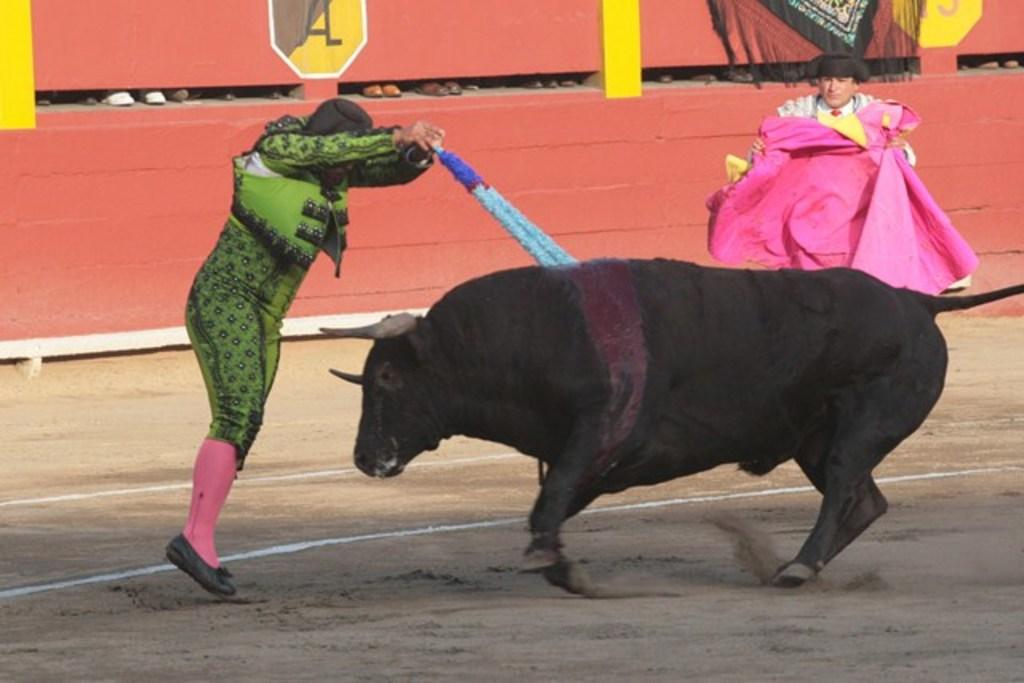Where was the image taken? The image is taken outside. How many people are in the image? There are two persons in the image. What else is present in the image besides the people? There is an animal in the image. What is the color of the animal? The animal is black in color. What is one person doing to the animal in the image? One person is pushing the animal with a stick. What type of tomatoes can be seen growing in the image? There are no tomatoes present in the image. Are the two persons in the image reading a book together? There is no indication in the image that the two persons are reading a book together. --- 